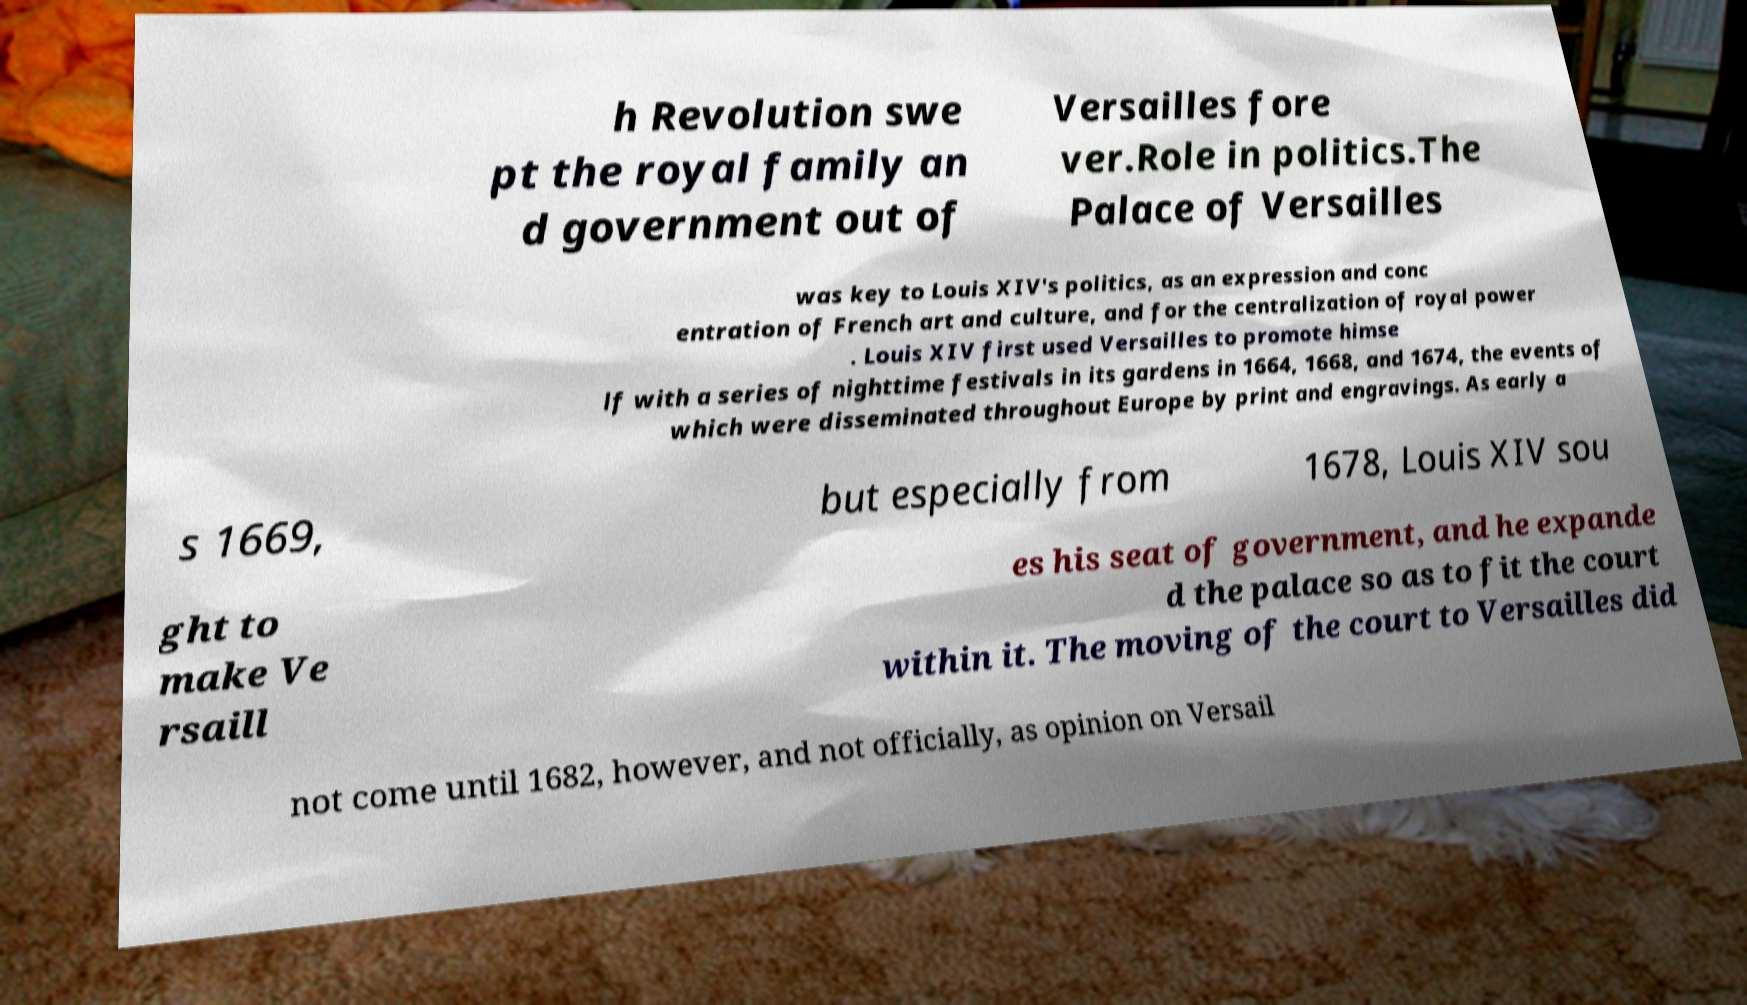For documentation purposes, I need the text within this image transcribed. Could you provide that? h Revolution swe pt the royal family an d government out of Versailles fore ver.Role in politics.The Palace of Versailles was key to Louis XIV's politics, as an expression and conc entration of French art and culture, and for the centralization of royal power . Louis XIV first used Versailles to promote himse lf with a series of nighttime festivals in its gardens in 1664, 1668, and 1674, the events of which were disseminated throughout Europe by print and engravings. As early a s 1669, but especially from 1678, Louis XIV sou ght to make Ve rsaill es his seat of government, and he expande d the palace so as to fit the court within it. The moving of the court to Versailles did not come until 1682, however, and not officially, as opinion on Versail 